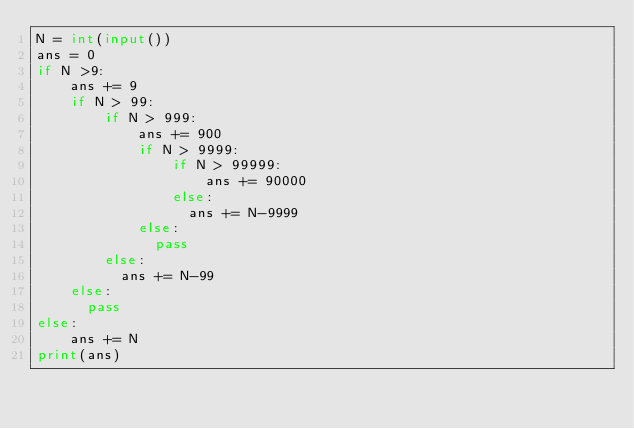Convert code to text. <code><loc_0><loc_0><loc_500><loc_500><_Python_>N = int(input())
ans = 0
if N >9:
    ans += 9
    if N > 99:
        if N > 999:
            ans += 900
            if N > 9999:
                if N > 99999:
                    ans += 90000
                else:
                  ans += N-9999
            else:
              pass   
        else:
          ans += N-99
    else:
      pass
else:
    ans += N
print(ans)</code> 